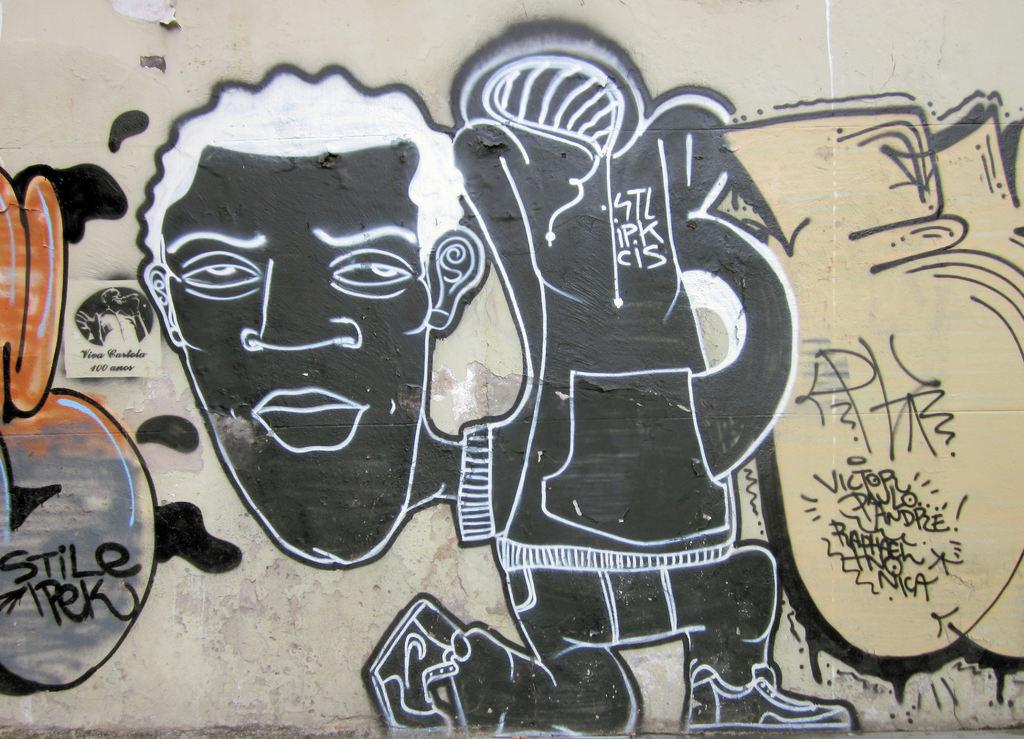What can be seen on the wall in the image? There are different types of paintings on the wall. Is there any text or writing on the wall? Yes, there is writing on the wall. How many children are playing in the prison in the image? There are no children or prison present in the image. What type of station is depicted in the image? There is no station depicted in the image. 